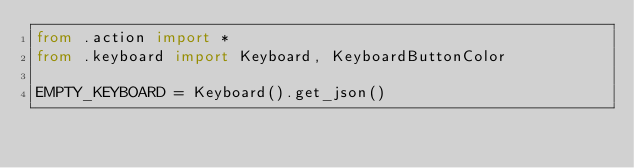<code> <loc_0><loc_0><loc_500><loc_500><_Python_>from .action import *
from .keyboard import Keyboard, KeyboardButtonColor

EMPTY_KEYBOARD = Keyboard().get_json()
</code> 